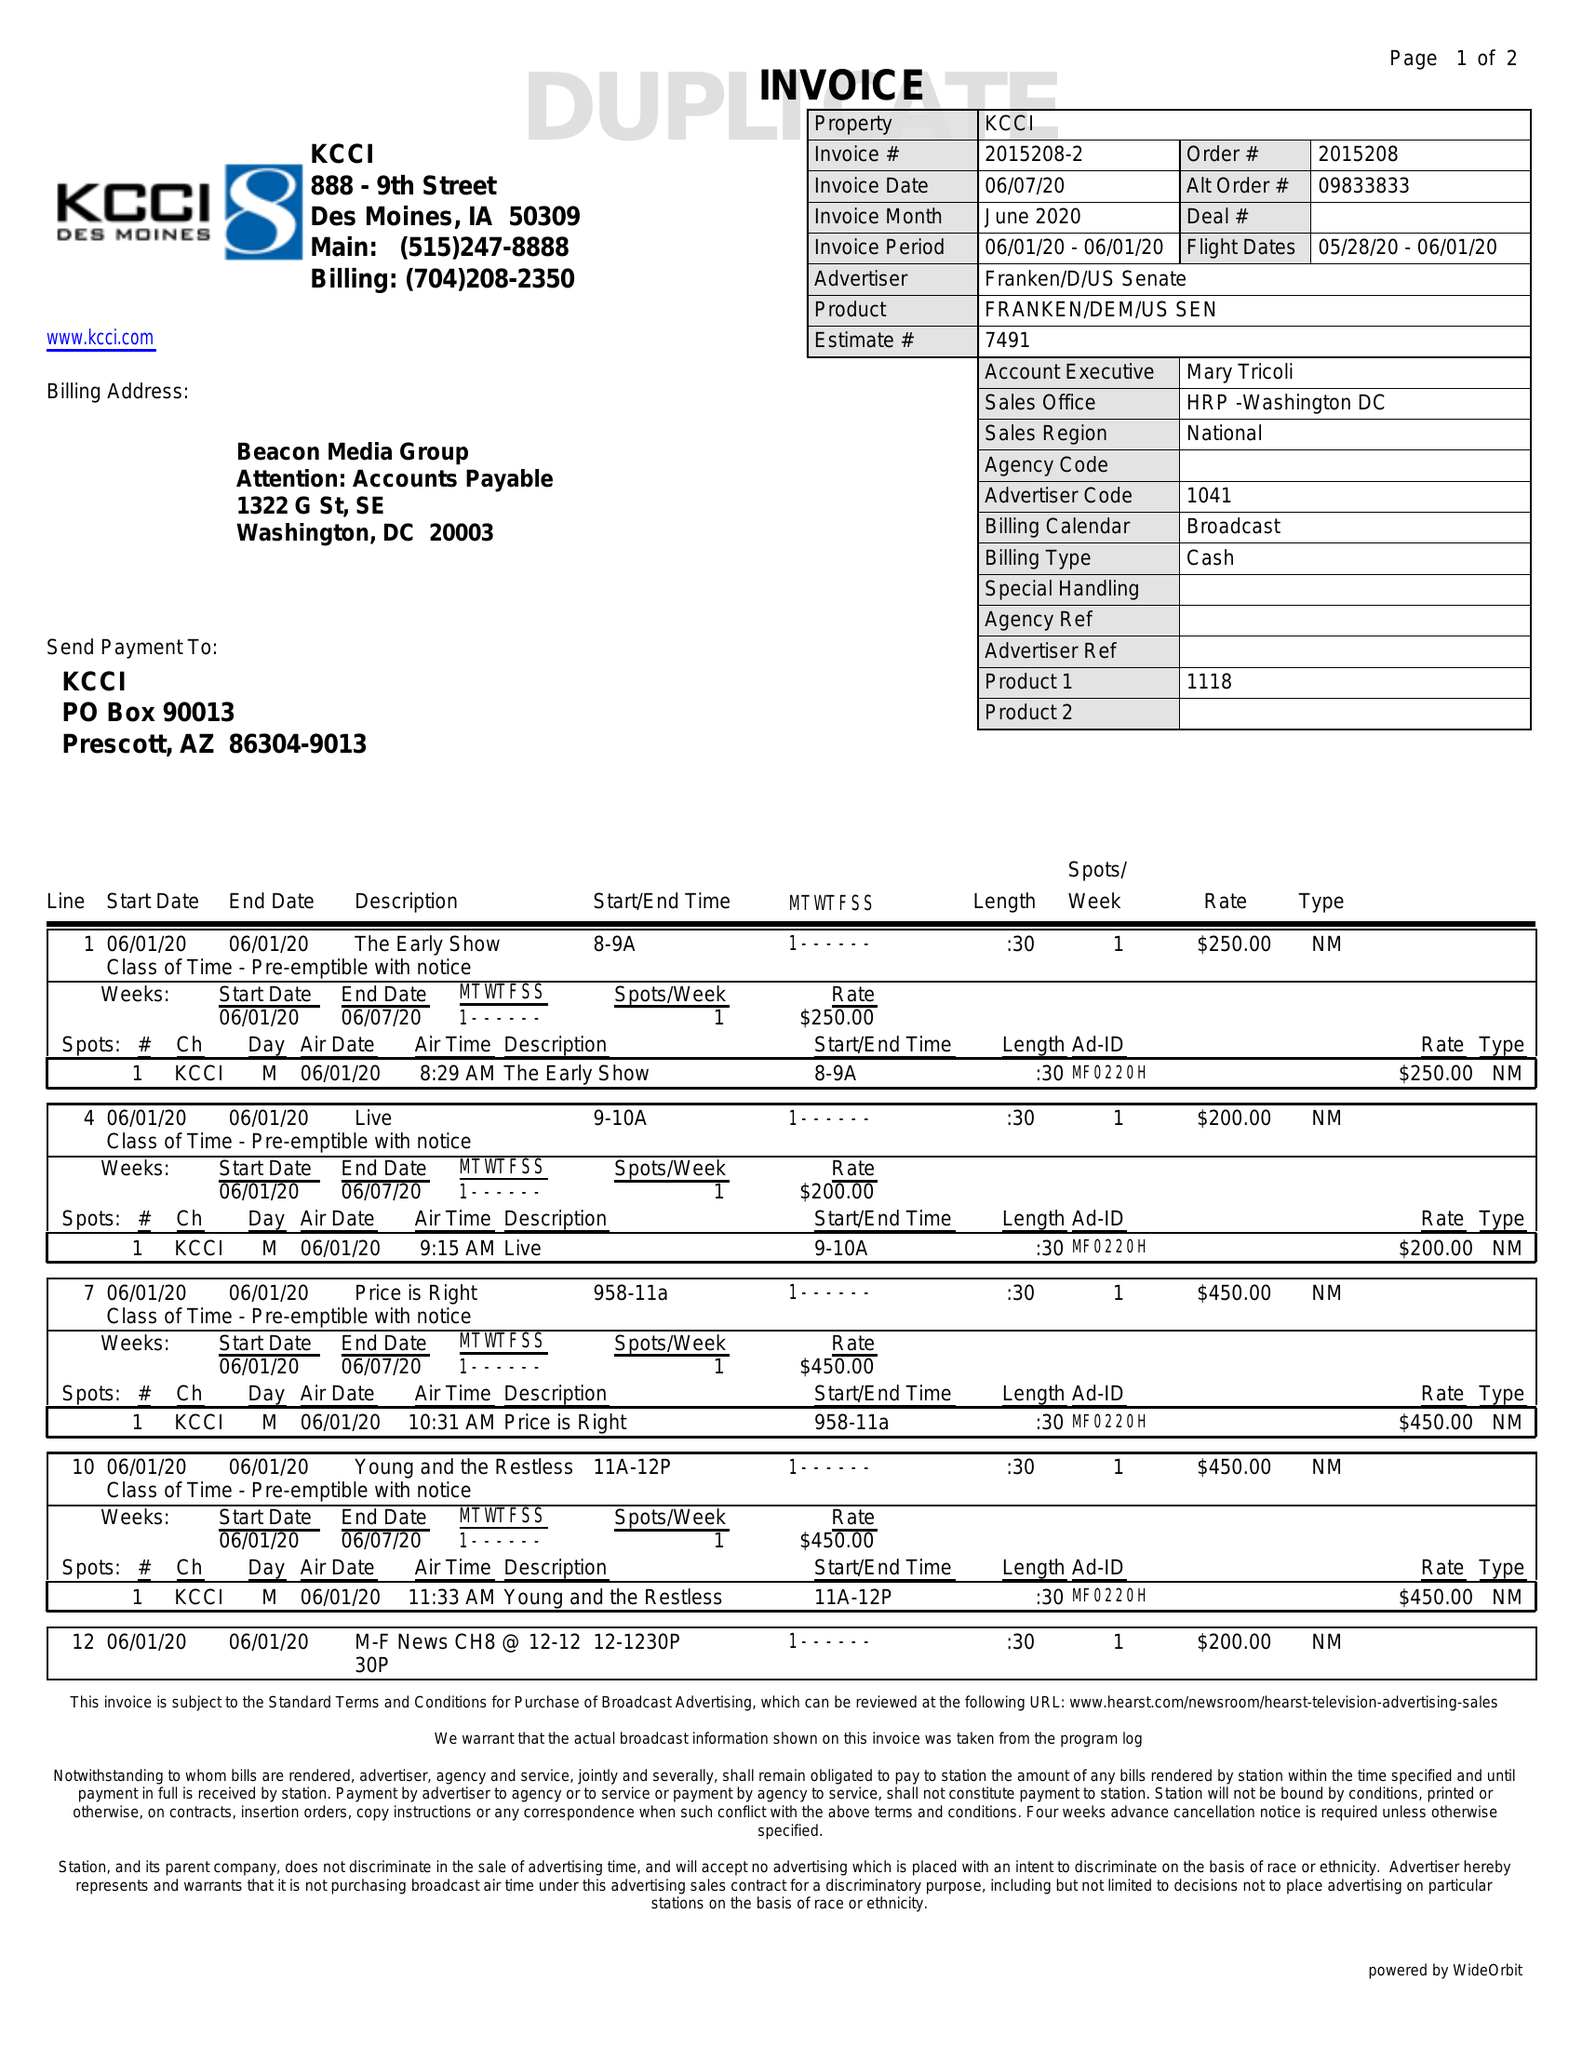What is the value for the contract_num?
Answer the question using a single word or phrase. 2015208 